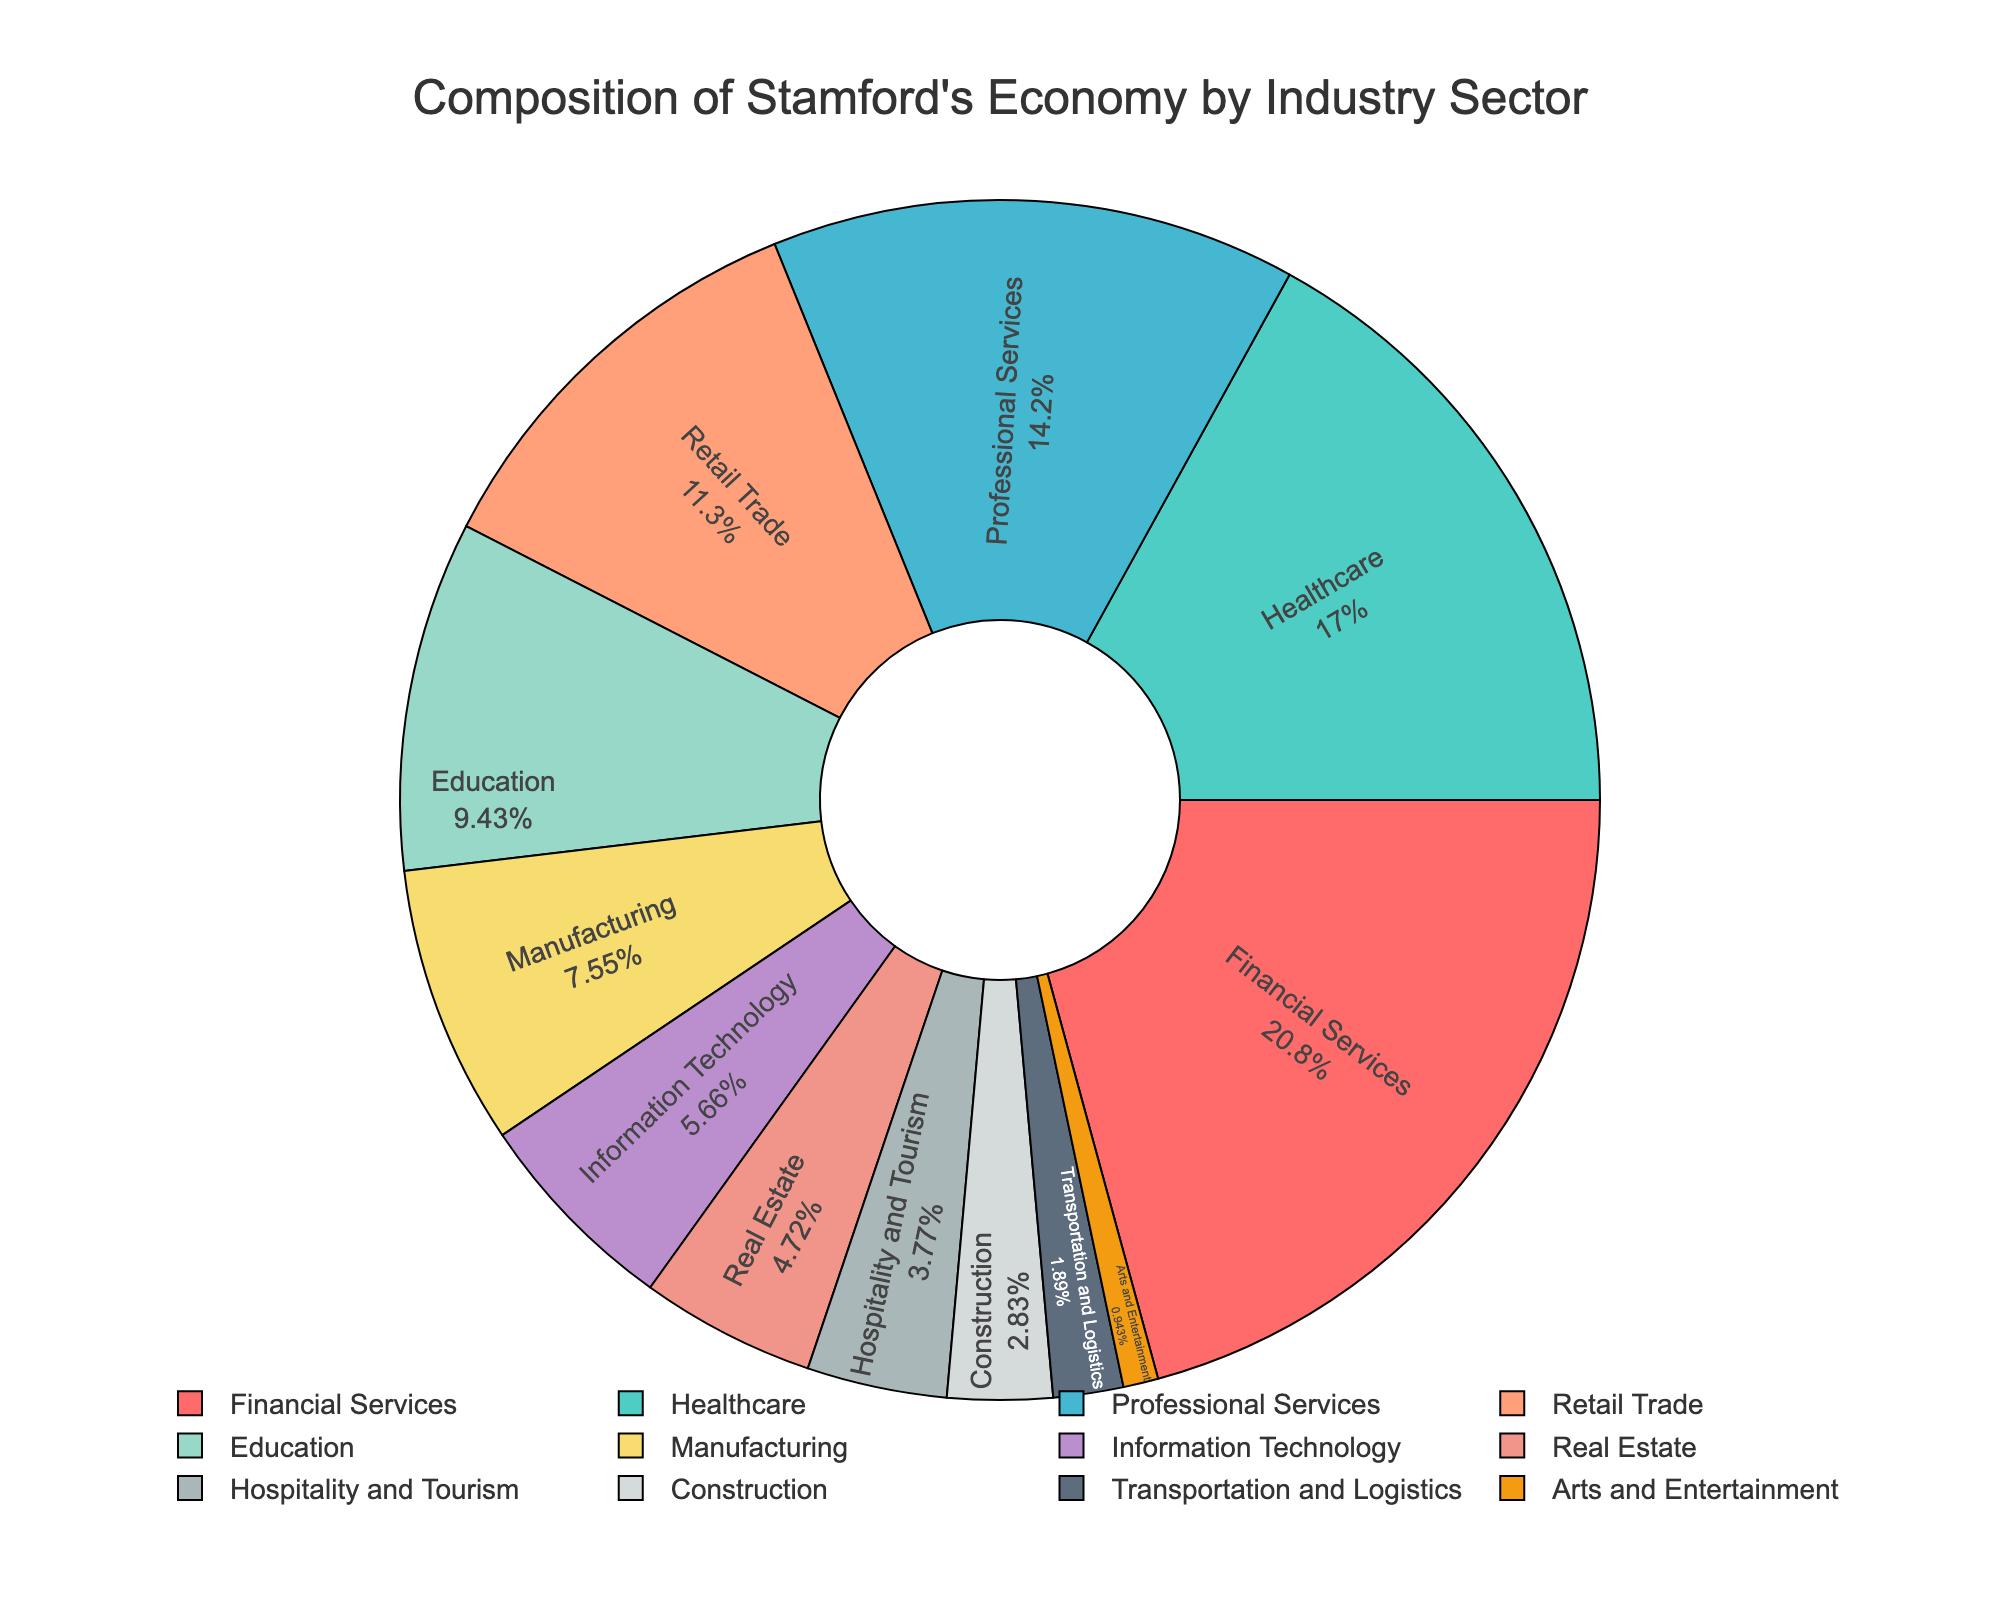Which industry sector dominates Stamford's economy? The sector with the largest percentage slice represents the dominant industry. According to the figure, Financial Services holds the largest share with 22%.
Answer: Financial Services What is the combined percentage of the Healthcare and Professional Services sectors? Add the percentages of Healthcare (18%) and Professional Services (15%). 18% + 15% = 33%.
Answer: 33% How much larger is the Retail Trade sector compared to the Information Technology sector? Subtract the percentage of Information Technology (6%) from Retail Trade (12%). 12% - 6% = 6%.
Answer: 6% What are the two smallest industry sectors in terms of percentage share? Identify the sectors with the smallest percentage slices. According to the figure, Arts and Entertainment (1%) and Transportation and Logistics (2%) are the smallest.
Answer: Arts and Entertainment, Transportation and Logistics Which color represents the Healthcare sector, and what is its percentage? Locate the sector labeled "Healthcare" and describe the corresponding color slice. The Healthcare sector has an 18% share and is represented by a green slice.
Answer: Green, 18% What percentage of Stamford's economy is attributed to sectors with less than 5% share each? Add the percentages of sectors with less than 5%: Hospitality and Tourism (4%), Construction (3%), Transportation and Logistics (2%), Arts and Entertainment (1%). 4% + 3% + 2% + 1% = 10%.
Answer: 10% If the percentages were to be rounded, which two sectors would become equal due to the rounding? Identify sectors whose percentages are close and would round to the same number. Construction (3%) and Transportation and Logistics (2%) both round to approximately 3%.
Answer: Construction, Transportation and Logistics How does the percentage share of the Manufacturing sector compare to that of the Education sector? Compare the percentages of Manufacturing (8%) and Education (10%). Manufacturing is 2% less than Education.
Answer: 2% less 